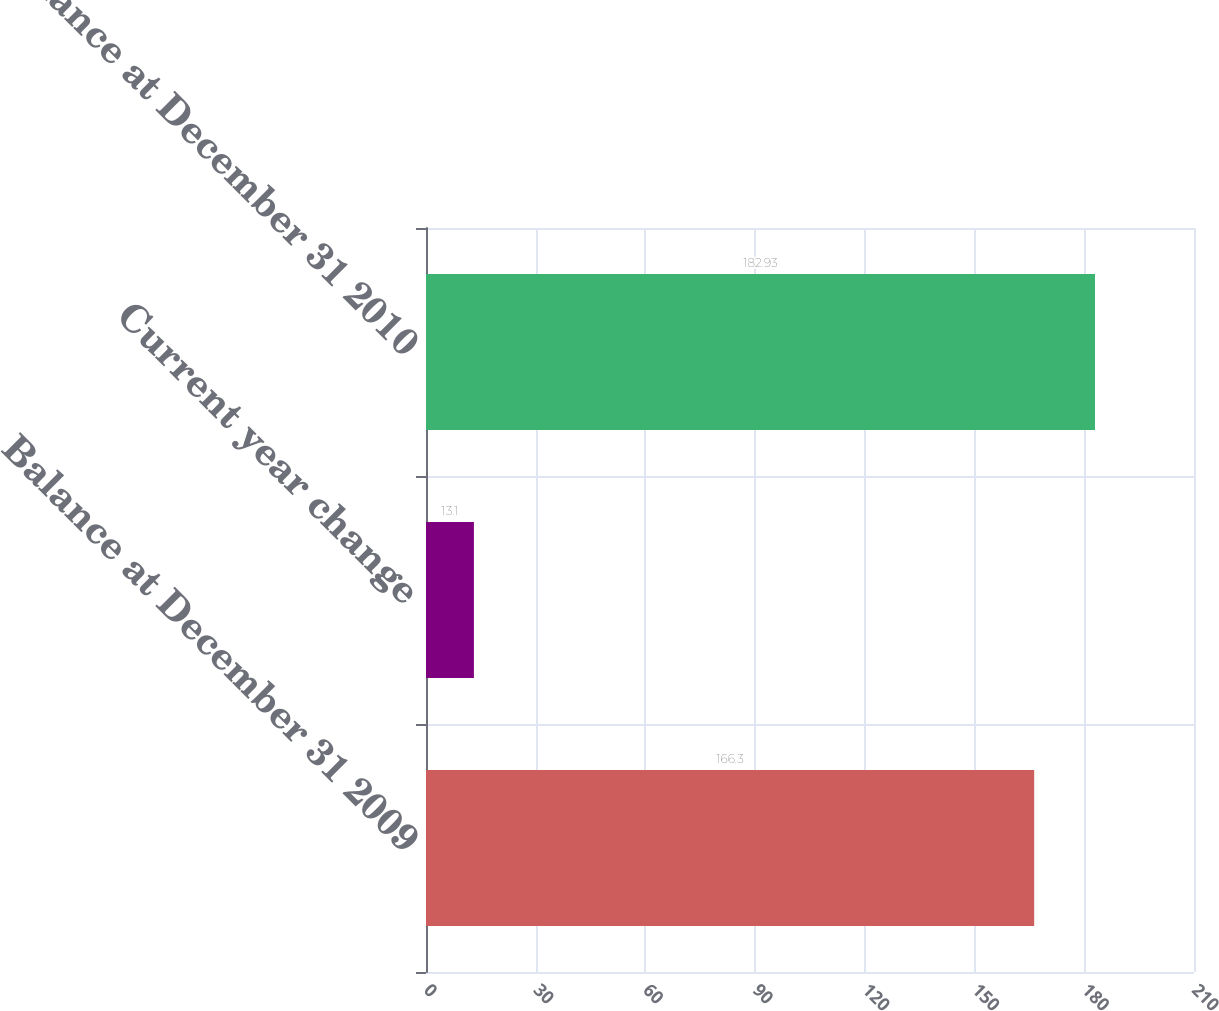Convert chart to OTSL. <chart><loc_0><loc_0><loc_500><loc_500><bar_chart><fcel>Balance at December 31 2009<fcel>Current year change<fcel>Balance at December 31 2010<nl><fcel>166.3<fcel>13.1<fcel>182.93<nl></chart> 